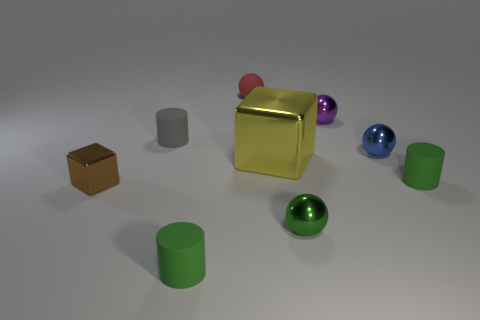Subtract all cubes. How many objects are left? 7 Add 8 tiny red matte spheres. How many tiny red matte spheres exist? 9 Subtract 1 brown cubes. How many objects are left? 8 Subtract all gray cylinders. Subtract all green cylinders. How many objects are left? 6 Add 7 brown shiny blocks. How many brown shiny blocks are left? 8 